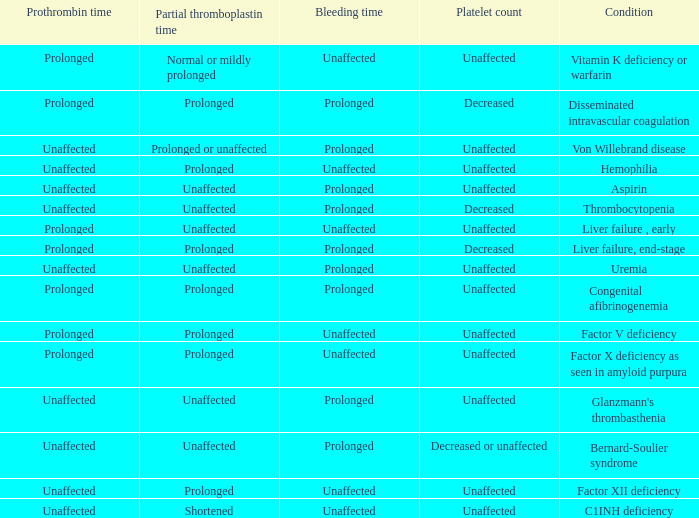In which bleeding situation does congenital afibrinogenemia occur? Prolonged. 